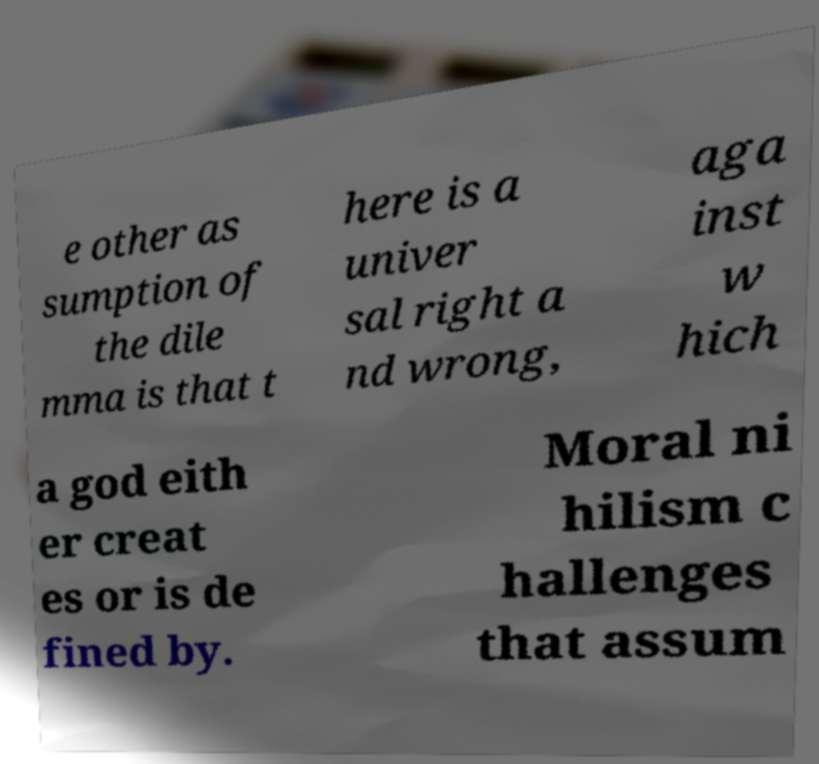Please identify and transcribe the text found in this image. e other as sumption of the dile mma is that t here is a univer sal right a nd wrong, aga inst w hich a god eith er creat es or is de fined by. Moral ni hilism c hallenges that assum 